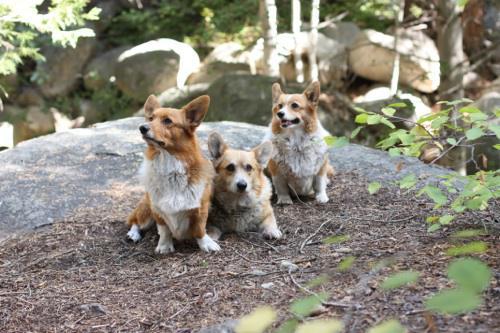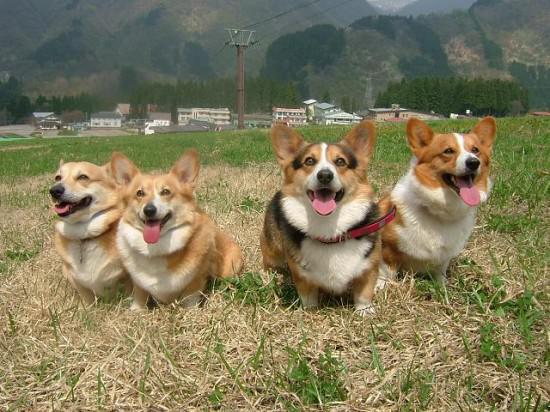The first image is the image on the left, the second image is the image on the right. Analyze the images presented: Is the assertion "The left image contains no more than two corgi dogs." valid? Answer yes or no. No. 